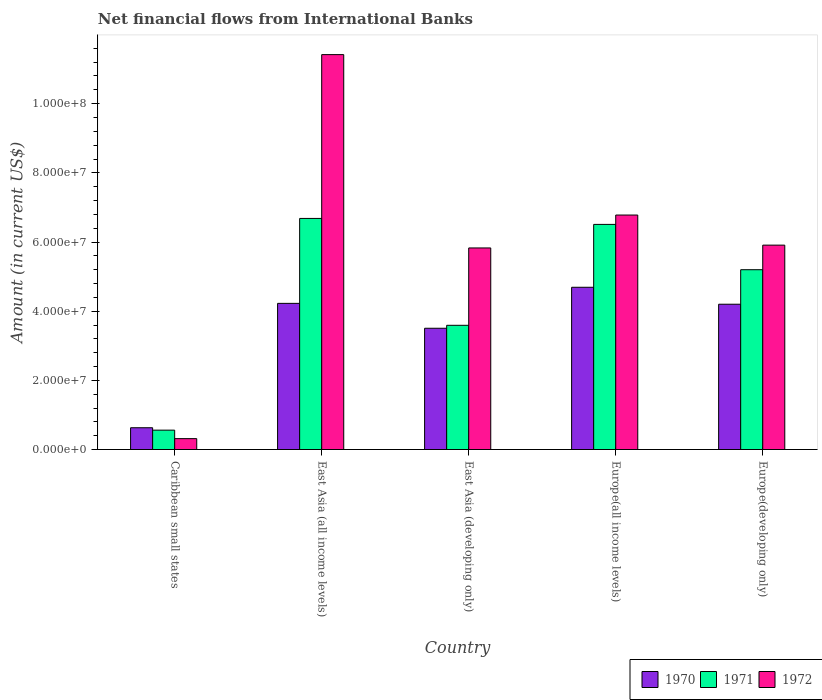Are the number of bars per tick equal to the number of legend labels?
Your answer should be very brief. Yes. Are the number of bars on each tick of the X-axis equal?
Your answer should be compact. Yes. How many bars are there on the 3rd tick from the left?
Make the answer very short. 3. How many bars are there on the 2nd tick from the right?
Offer a very short reply. 3. What is the label of the 5th group of bars from the left?
Provide a short and direct response. Europe(developing only). What is the net financial aid flows in 1972 in Europe(all income levels)?
Your answer should be very brief. 6.78e+07. Across all countries, what is the maximum net financial aid flows in 1970?
Your response must be concise. 4.69e+07. Across all countries, what is the minimum net financial aid flows in 1970?
Your answer should be compact. 6.30e+06. In which country was the net financial aid flows in 1971 maximum?
Your answer should be very brief. East Asia (all income levels). In which country was the net financial aid flows in 1972 minimum?
Give a very brief answer. Caribbean small states. What is the total net financial aid flows in 1970 in the graph?
Ensure brevity in your answer.  1.73e+08. What is the difference between the net financial aid flows in 1972 in East Asia (developing only) and that in Europe(all income levels)?
Provide a succinct answer. -9.52e+06. What is the difference between the net financial aid flows in 1971 in Europe(developing only) and the net financial aid flows in 1972 in East Asia (developing only)?
Your response must be concise. -6.29e+06. What is the average net financial aid flows in 1972 per country?
Your response must be concise. 6.05e+07. What is the difference between the net financial aid flows of/in 1971 and net financial aid flows of/in 1972 in East Asia (all income levels)?
Your answer should be compact. -4.74e+07. In how many countries, is the net financial aid flows in 1972 greater than 72000000 US$?
Offer a terse response. 1. What is the ratio of the net financial aid flows in 1971 in East Asia (developing only) to that in Europe(all income levels)?
Your response must be concise. 0.55. Is the net financial aid flows in 1972 in East Asia (developing only) less than that in Europe(all income levels)?
Offer a very short reply. Yes. What is the difference between the highest and the second highest net financial aid flows in 1970?
Keep it short and to the point. 4.65e+06. What is the difference between the highest and the lowest net financial aid flows in 1972?
Keep it short and to the point. 1.11e+08. Is the sum of the net financial aid flows in 1970 in East Asia (all income levels) and Europe(all income levels) greater than the maximum net financial aid flows in 1972 across all countries?
Your answer should be very brief. No. What does the 3rd bar from the left in Europe(developing only) represents?
Provide a short and direct response. 1972. What does the 2nd bar from the right in East Asia (all income levels) represents?
Offer a very short reply. 1971. Is it the case that in every country, the sum of the net financial aid flows in 1972 and net financial aid flows in 1970 is greater than the net financial aid flows in 1971?
Your answer should be very brief. Yes. How many countries are there in the graph?
Offer a terse response. 5. Are the values on the major ticks of Y-axis written in scientific E-notation?
Provide a short and direct response. Yes. Does the graph contain grids?
Give a very brief answer. No. How are the legend labels stacked?
Offer a very short reply. Horizontal. What is the title of the graph?
Offer a very short reply. Net financial flows from International Banks. Does "1970" appear as one of the legend labels in the graph?
Provide a short and direct response. Yes. What is the label or title of the X-axis?
Offer a terse response. Country. What is the Amount (in current US$) in 1970 in Caribbean small states?
Make the answer very short. 6.30e+06. What is the Amount (in current US$) of 1971 in Caribbean small states?
Your answer should be compact. 5.60e+06. What is the Amount (in current US$) of 1972 in Caribbean small states?
Your answer should be very brief. 3.15e+06. What is the Amount (in current US$) in 1970 in East Asia (all income levels)?
Keep it short and to the point. 4.23e+07. What is the Amount (in current US$) of 1971 in East Asia (all income levels)?
Your answer should be very brief. 6.68e+07. What is the Amount (in current US$) of 1972 in East Asia (all income levels)?
Ensure brevity in your answer.  1.14e+08. What is the Amount (in current US$) of 1970 in East Asia (developing only)?
Give a very brief answer. 3.51e+07. What is the Amount (in current US$) of 1971 in East Asia (developing only)?
Keep it short and to the point. 3.59e+07. What is the Amount (in current US$) of 1972 in East Asia (developing only)?
Offer a terse response. 5.83e+07. What is the Amount (in current US$) in 1970 in Europe(all income levels)?
Give a very brief answer. 4.69e+07. What is the Amount (in current US$) in 1971 in Europe(all income levels)?
Provide a short and direct response. 6.51e+07. What is the Amount (in current US$) in 1972 in Europe(all income levels)?
Provide a succinct answer. 6.78e+07. What is the Amount (in current US$) of 1970 in Europe(developing only)?
Your answer should be compact. 4.20e+07. What is the Amount (in current US$) of 1971 in Europe(developing only)?
Offer a terse response. 5.20e+07. What is the Amount (in current US$) of 1972 in Europe(developing only)?
Make the answer very short. 5.91e+07. Across all countries, what is the maximum Amount (in current US$) in 1970?
Offer a terse response. 4.69e+07. Across all countries, what is the maximum Amount (in current US$) of 1971?
Your answer should be very brief. 6.68e+07. Across all countries, what is the maximum Amount (in current US$) in 1972?
Your answer should be very brief. 1.14e+08. Across all countries, what is the minimum Amount (in current US$) of 1970?
Your response must be concise. 6.30e+06. Across all countries, what is the minimum Amount (in current US$) of 1971?
Your answer should be very brief. 5.60e+06. Across all countries, what is the minimum Amount (in current US$) in 1972?
Make the answer very short. 3.15e+06. What is the total Amount (in current US$) of 1970 in the graph?
Ensure brevity in your answer.  1.73e+08. What is the total Amount (in current US$) of 1971 in the graph?
Your answer should be compact. 2.25e+08. What is the total Amount (in current US$) of 1972 in the graph?
Your response must be concise. 3.03e+08. What is the difference between the Amount (in current US$) of 1970 in Caribbean small states and that in East Asia (all income levels)?
Your answer should be very brief. -3.60e+07. What is the difference between the Amount (in current US$) of 1971 in Caribbean small states and that in East Asia (all income levels)?
Ensure brevity in your answer.  -6.12e+07. What is the difference between the Amount (in current US$) in 1972 in Caribbean small states and that in East Asia (all income levels)?
Your answer should be very brief. -1.11e+08. What is the difference between the Amount (in current US$) in 1970 in Caribbean small states and that in East Asia (developing only)?
Make the answer very short. -2.88e+07. What is the difference between the Amount (in current US$) in 1971 in Caribbean small states and that in East Asia (developing only)?
Your answer should be very brief. -3.03e+07. What is the difference between the Amount (in current US$) in 1972 in Caribbean small states and that in East Asia (developing only)?
Keep it short and to the point. -5.51e+07. What is the difference between the Amount (in current US$) of 1970 in Caribbean small states and that in Europe(all income levels)?
Give a very brief answer. -4.06e+07. What is the difference between the Amount (in current US$) of 1971 in Caribbean small states and that in Europe(all income levels)?
Your answer should be compact. -5.95e+07. What is the difference between the Amount (in current US$) of 1972 in Caribbean small states and that in Europe(all income levels)?
Make the answer very short. -6.46e+07. What is the difference between the Amount (in current US$) of 1970 in Caribbean small states and that in Europe(developing only)?
Offer a terse response. -3.57e+07. What is the difference between the Amount (in current US$) of 1971 in Caribbean small states and that in Europe(developing only)?
Your answer should be very brief. -4.64e+07. What is the difference between the Amount (in current US$) of 1972 in Caribbean small states and that in Europe(developing only)?
Provide a short and direct response. -5.59e+07. What is the difference between the Amount (in current US$) of 1970 in East Asia (all income levels) and that in East Asia (developing only)?
Your answer should be very brief. 7.20e+06. What is the difference between the Amount (in current US$) of 1971 in East Asia (all income levels) and that in East Asia (developing only)?
Offer a terse response. 3.09e+07. What is the difference between the Amount (in current US$) in 1972 in East Asia (all income levels) and that in East Asia (developing only)?
Your response must be concise. 5.59e+07. What is the difference between the Amount (in current US$) of 1970 in East Asia (all income levels) and that in Europe(all income levels)?
Ensure brevity in your answer.  -4.65e+06. What is the difference between the Amount (in current US$) of 1971 in East Asia (all income levels) and that in Europe(all income levels)?
Your answer should be compact. 1.72e+06. What is the difference between the Amount (in current US$) of 1972 in East Asia (all income levels) and that in Europe(all income levels)?
Provide a short and direct response. 4.64e+07. What is the difference between the Amount (in current US$) of 1970 in East Asia (all income levels) and that in Europe(developing only)?
Make the answer very short. 2.48e+05. What is the difference between the Amount (in current US$) in 1971 in East Asia (all income levels) and that in Europe(developing only)?
Your response must be concise. 1.48e+07. What is the difference between the Amount (in current US$) in 1972 in East Asia (all income levels) and that in Europe(developing only)?
Ensure brevity in your answer.  5.51e+07. What is the difference between the Amount (in current US$) in 1970 in East Asia (developing only) and that in Europe(all income levels)?
Your answer should be compact. -1.19e+07. What is the difference between the Amount (in current US$) in 1971 in East Asia (developing only) and that in Europe(all income levels)?
Make the answer very short. -2.92e+07. What is the difference between the Amount (in current US$) of 1972 in East Asia (developing only) and that in Europe(all income levels)?
Offer a very short reply. -9.52e+06. What is the difference between the Amount (in current US$) of 1970 in East Asia (developing only) and that in Europe(developing only)?
Offer a very short reply. -6.95e+06. What is the difference between the Amount (in current US$) in 1971 in East Asia (developing only) and that in Europe(developing only)?
Your answer should be very brief. -1.61e+07. What is the difference between the Amount (in current US$) of 1972 in East Asia (developing only) and that in Europe(developing only)?
Ensure brevity in your answer.  -8.15e+05. What is the difference between the Amount (in current US$) of 1970 in Europe(all income levels) and that in Europe(developing only)?
Provide a succinct answer. 4.90e+06. What is the difference between the Amount (in current US$) of 1971 in Europe(all income levels) and that in Europe(developing only)?
Provide a short and direct response. 1.31e+07. What is the difference between the Amount (in current US$) in 1972 in Europe(all income levels) and that in Europe(developing only)?
Offer a terse response. 8.70e+06. What is the difference between the Amount (in current US$) of 1970 in Caribbean small states and the Amount (in current US$) of 1971 in East Asia (all income levels)?
Make the answer very short. -6.05e+07. What is the difference between the Amount (in current US$) in 1970 in Caribbean small states and the Amount (in current US$) in 1972 in East Asia (all income levels)?
Ensure brevity in your answer.  -1.08e+08. What is the difference between the Amount (in current US$) of 1971 in Caribbean small states and the Amount (in current US$) of 1972 in East Asia (all income levels)?
Your answer should be very brief. -1.09e+08. What is the difference between the Amount (in current US$) of 1970 in Caribbean small states and the Amount (in current US$) of 1971 in East Asia (developing only)?
Make the answer very short. -2.96e+07. What is the difference between the Amount (in current US$) in 1970 in Caribbean small states and the Amount (in current US$) in 1972 in East Asia (developing only)?
Make the answer very short. -5.20e+07. What is the difference between the Amount (in current US$) in 1971 in Caribbean small states and the Amount (in current US$) in 1972 in East Asia (developing only)?
Give a very brief answer. -5.27e+07. What is the difference between the Amount (in current US$) of 1970 in Caribbean small states and the Amount (in current US$) of 1971 in Europe(all income levels)?
Your answer should be very brief. -5.88e+07. What is the difference between the Amount (in current US$) of 1970 in Caribbean small states and the Amount (in current US$) of 1972 in Europe(all income levels)?
Offer a very short reply. -6.15e+07. What is the difference between the Amount (in current US$) of 1971 in Caribbean small states and the Amount (in current US$) of 1972 in Europe(all income levels)?
Make the answer very short. -6.22e+07. What is the difference between the Amount (in current US$) in 1970 in Caribbean small states and the Amount (in current US$) in 1971 in Europe(developing only)?
Your response must be concise. -4.57e+07. What is the difference between the Amount (in current US$) in 1970 in Caribbean small states and the Amount (in current US$) in 1972 in Europe(developing only)?
Your response must be concise. -5.28e+07. What is the difference between the Amount (in current US$) of 1971 in Caribbean small states and the Amount (in current US$) of 1972 in Europe(developing only)?
Ensure brevity in your answer.  -5.35e+07. What is the difference between the Amount (in current US$) of 1970 in East Asia (all income levels) and the Amount (in current US$) of 1971 in East Asia (developing only)?
Give a very brief answer. 6.34e+06. What is the difference between the Amount (in current US$) of 1970 in East Asia (all income levels) and the Amount (in current US$) of 1972 in East Asia (developing only)?
Offer a very short reply. -1.60e+07. What is the difference between the Amount (in current US$) of 1971 in East Asia (all income levels) and the Amount (in current US$) of 1972 in East Asia (developing only)?
Provide a short and direct response. 8.53e+06. What is the difference between the Amount (in current US$) of 1970 in East Asia (all income levels) and the Amount (in current US$) of 1971 in Europe(all income levels)?
Your response must be concise. -2.28e+07. What is the difference between the Amount (in current US$) of 1970 in East Asia (all income levels) and the Amount (in current US$) of 1972 in Europe(all income levels)?
Keep it short and to the point. -2.55e+07. What is the difference between the Amount (in current US$) in 1971 in East Asia (all income levels) and the Amount (in current US$) in 1972 in Europe(all income levels)?
Your response must be concise. -9.81e+05. What is the difference between the Amount (in current US$) in 1970 in East Asia (all income levels) and the Amount (in current US$) in 1971 in Europe(developing only)?
Keep it short and to the point. -9.73e+06. What is the difference between the Amount (in current US$) in 1970 in East Asia (all income levels) and the Amount (in current US$) in 1972 in Europe(developing only)?
Provide a succinct answer. -1.68e+07. What is the difference between the Amount (in current US$) in 1971 in East Asia (all income levels) and the Amount (in current US$) in 1972 in Europe(developing only)?
Offer a terse response. 7.72e+06. What is the difference between the Amount (in current US$) in 1970 in East Asia (developing only) and the Amount (in current US$) in 1971 in Europe(all income levels)?
Provide a short and direct response. -3.00e+07. What is the difference between the Amount (in current US$) of 1970 in East Asia (developing only) and the Amount (in current US$) of 1972 in Europe(all income levels)?
Your response must be concise. -3.27e+07. What is the difference between the Amount (in current US$) in 1971 in East Asia (developing only) and the Amount (in current US$) in 1972 in Europe(all income levels)?
Ensure brevity in your answer.  -3.19e+07. What is the difference between the Amount (in current US$) of 1970 in East Asia (developing only) and the Amount (in current US$) of 1971 in Europe(developing only)?
Provide a short and direct response. -1.69e+07. What is the difference between the Amount (in current US$) of 1970 in East Asia (developing only) and the Amount (in current US$) of 1972 in Europe(developing only)?
Your answer should be compact. -2.40e+07. What is the difference between the Amount (in current US$) in 1971 in East Asia (developing only) and the Amount (in current US$) in 1972 in Europe(developing only)?
Offer a terse response. -2.32e+07. What is the difference between the Amount (in current US$) in 1970 in Europe(all income levels) and the Amount (in current US$) in 1971 in Europe(developing only)?
Your answer should be compact. -5.08e+06. What is the difference between the Amount (in current US$) in 1970 in Europe(all income levels) and the Amount (in current US$) in 1972 in Europe(developing only)?
Give a very brief answer. -1.22e+07. What is the difference between the Amount (in current US$) of 1971 in Europe(all income levels) and the Amount (in current US$) of 1972 in Europe(developing only)?
Offer a terse response. 6.00e+06. What is the average Amount (in current US$) of 1970 per country?
Make the answer very short. 3.45e+07. What is the average Amount (in current US$) in 1971 per country?
Provide a short and direct response. 4.51e+07. What is the average Amount (in current US$) in 1972 per country?
Give a very brief answer. 6.05e+07. What is the difference between the Amount (in current US$) of 1970 and Amount (in current US$) of 1971 in Caribbean small states?
Keep it short and to the point. 6.96e+05. What is the difference between the Amount (in current US$) in 1970 and Amount (in current US$) in 1972 in Caribbean small states?
Offer a very short reply. 3.15e+06. What is the difference between the Amount (in current US$) in 1971 and Amount (in current US$) in 1972 in Caribbean small states?
Provide a short and direct response. 2.45e+06. What is the difference between the Amount (in current US$) in 1970 and Amount (in current US$) in 1971 in East Asia (all income levels)?
Your answer should be very brief. -2.46e+07. What is the difference between the Amount (in current US$) of 1970 and Amount (in current US$) of 1972 in East Asia (all income levels)?
Provide a succinct answer. -7.19e+07. What is the difference between the Amount (in current US$) in 1971 and Amount (in current US$) in 1972 in East Asia (all income levels)?
Your response must be concise. -4.74e+07. What is the difference between the Amount (in current US$) of 1970 and Amount (in current US$) of 1971 in East Asia (developing only)?
Keep it short and to the point. -8.55e+05. What is the difference between the Amount (in current US$) in 1970 and Amount (in current US$) in 1972 in East Asia (developing only)?
Your answer should be very brief. -2.32e+07. What is the difference between the Amount (in current US$) in 1971 and Amount (in current US$) in 1972 in East Asia (developing only)?
Keep it short and to the point. -2.24e+07. What is the difference between the Amount (in current US$) in 1970 and Amount (in current US$) in 1971 in Europe(all income levels)?
Provide a short and direct response. -1.82e+07. What is the difference between the Amount (in current US$) in 1970 and Amount (in current US$) in 1972 in Europe(all income levels)?
Your answer should be compact. -2.09e+07. What is the difference between the Amount (in current US$) of 1971 and Amount (in current US$) of 1972 in Europe(all income levels)?
Give a very brief answer. -2.70e+06. What is the difference between the Amount (in current US$) in 1970 and Amount (in current US$) in 1971 in Europe(developing only)?
Provide a succinct answer. -9.98e+06. What is the difference between the Amount (in current US$) in 1970 and Amount (in current US$) in 1972 in Europe(developing only)?
Provide a succinct answer. -1.71e+07. What is the difference between the Amount (in current US$) in 1971 and Amount (in current US$) in 1972 in Europe(developing only)?
Offer a very short reply. -7.10e+06. What is the ratio of the Amount (in current US$) of 1970 in Caribbean small states to that in East Asia (all income levels)?
Make the answer very short. 0.15. What is the ratio of the Amount (in current US$) of 1971 in Caribbean small states to that in East Asia (all income levels)?
Give a very brief answer. 0.08. What is the ratio of the Amount (in current US$) of 1972 in Caribbean small states to that in East Asia (all income levels)?
Offer a terse response. 0.03. What is the ratio of the Amount (in current US$) of 1970 in Caribbean small states to that in East Asia (developing only)?
Make the answer very short. 0.18. What is the ratio of the Amount (in current US$) in 1971 in Caribbean small states to that in East Asia (developing only)?
Offer a terse response. 0.16. What is the ratio of the Amount (in current US$) in 1972 in Caribbean small states to that in East Asia (developing only)?
Give a very brief answer. 0.05. What is the ratio of the Amount (in current US$) of 1970 in Caribbean small states to that in Europe(all income levels)?
Provide a succinct answer. 0.13. What is the ratio of the Amount (in current US$) of 1971 in Caribbean small states to that in Europe(all income levels)?
Provide a short and direct response. 0.09. What is the ratio of the Amount (in current US$) in 1972 in Caribbean small states to that in Europe(all income levels)?
Offer a very short reply. 0.05. What is the ratio of the Amount (in current US$) of 1970 in Caribbean small states to that in Europe(developing only)?
Your answer should be very brief. 0.15. What is the ratio of the Amount (in current US$) of 1971 in Caribbean small states to that in Europe(developing only)?
Your answer should be compact. 0.11. What is the ratio of the Amount (in current US$) of 1972 in Caribbean small states to that in Europe(developing only)?
Your response must be concise. 0.05. What is the ratio of the Amount (in current US$) of 1970 in East Asia (all income levels) to that in East Asia (developing only)?
Your answer should be compact. 1.21. What is the ratio of the Amount (in current US$) in 1971 in East Asia (all income levels) to that in East Asia (developing only)?
Provide a succinct answer. 1.86. What is the ratio of the Amount (in current US$) in 1972 in East Asia (all income levels) to that in East Asia (developing only)?
Keep it short and to the point. 1.96. What is the ratio of the Amount (in current US$) of 1970 in East Asia (all income levels) to that in Europe(all income levels)?
Offer a terse response. 0.9. What is the ratio of the Amount (in current US$) in 1971 in East Asia (all income levels) to that in Europe(all income levels)?
Offer a terse response. 1.03. What is the ratio of the Amount (in current US$) in 1972 in East Asia (all income levels) to that in Europe(all income levels)?
Offer a terse response. 1.68. What is the ratio of the Amount (in current US$) in 1970 in East Asia (all income levels) to that in Europe(developing only)?
Provide a succinct answer. 1.01. What is the ratio of the Amount (in current US$) in 1971 in East Asia (all income levels) to that in Europe(developing only)?
Make the answer very short. 1.29. What is the ratio of the Amount (in current US$) of 1972 in East Asia (all income levels) to that in Europe(developing only)?
Provide a short and direct response. 1.93. What is the ratio of the Amount (in current US$) in 1970 in East Asia (developing only) to that in Europe(all income levels)?
Offer a very short reply. 0.75. What is the ratio of the Amount (in current US$) in 1971 in East Asia (developing only) to that in Europe(all income levels)?
Your answer should be compact. 0.55. What is the ratio of the Amount (in current US$) of 1972 in East Asia (developing only) to that in Europe(all income levels)?
Provide a short and direct response. 0.86. What is the ratio of the Amount (in current US$) in 1970 in East Asia (developing only) to that in Europe(developing only)?
Give a very brief answer. 0.83. What is the ratio of the Amount (in current US$) of 1971 in East Asia (developing only) to that in Europe(developing only)?
Make the answer very short. 0.69. What is the ratio of the Amount (in current US$) of 1972 in East Asia (developing only) to that in Europe(developing only)?
Your response must be concise. 0.99. What is the ratio of the Amount (in current US$) in 1970 in Europe(all income levels) to that in Europe(developing only)?
Your response must be concise. 1.12. What is the ratio of the Amount (in current US$) in 1971 in Europe(all income levels) to that in Europe(developing only)?
Ensure brevity in your answer.  1.25. What is the ratio of the Amount (in current US$) of 1972 in Europe(all income levels) to that in Europe(developing only)?
Provide a short and direct response. 1.15. What is the difference between the highest and the second highest Amount (in current US$) in 1970?
Provide a short and direct response. 4.65e+06. What is the difference between the highest and the second highest Amount (in current US$) in 1971?
Ensure brevity in your answer.  1.72e+06. What is the difference between the highest and the second highest Amount (in current US$) of 1972?
Make the answer very short. 4.64e+07. What is the difference between the highest and the lowest Amount (in current US$) in 1970?
Offer a very short reply. 4.06e+07. What is the difference between the highest and the lowest Amount (in current US$) of 1971?
Your answer should be compact. 6.12e+07. What is the difference between the highest and the lowest Amount (in current US$) of 1972?
Your response must be concise. 1.11e+08. 